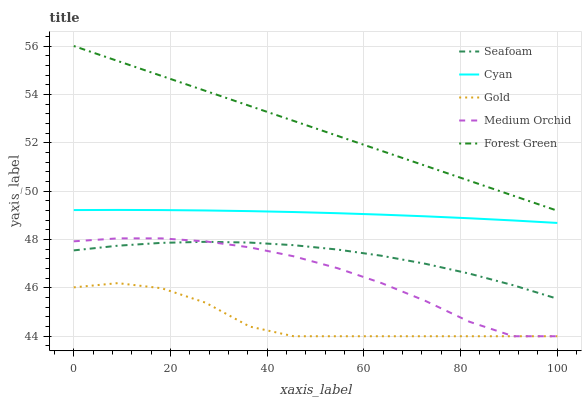Does Gold have the minimum area under the curve?
Answer yes or no. Yes. Does Forest Green have the maximum area under the curve?
Answer yes or no. Yes. Does Medium Orchid have the minimum area under the curve?
Answer yes or no. No. Does Medium Orchid have the maximum area under the curve?
Answer yes or no. No. Is Forest Green the smoothest?
Answer yes or no. Yes. Is Gold the roughest?
Answer yes or no. Yes. Is Medium Orchid the smoothest?
Answer yes or no. No. Is Medium Orchid the roughest?
Answer yes or no. No. Does Medium Orchid have the lowest value?
Answer yes or no. Yes. Does Forest Green have the lowest value?
Answer yes or no. No. Does Forest Green have the highest value?
Answer yes or no. Yes. Does Medium Orchid have the highest value?
Answer yes or no. No. Is Medium Orchid less than Forest Green?
Answer yes or no. Yes. Is Seafoam greater than Gold?
Answer yes or no. Yes. Does Medium Orchid intersect Gold?
Answer yes or no. Yes. Is Medium Orchid less than Gold?
Answer yes or no. No. Is Medium Orchid greater than Gold?
Answer yes or no. No. Does Medium Orchid intersect Forest Green?
Answer yes or no. No. 